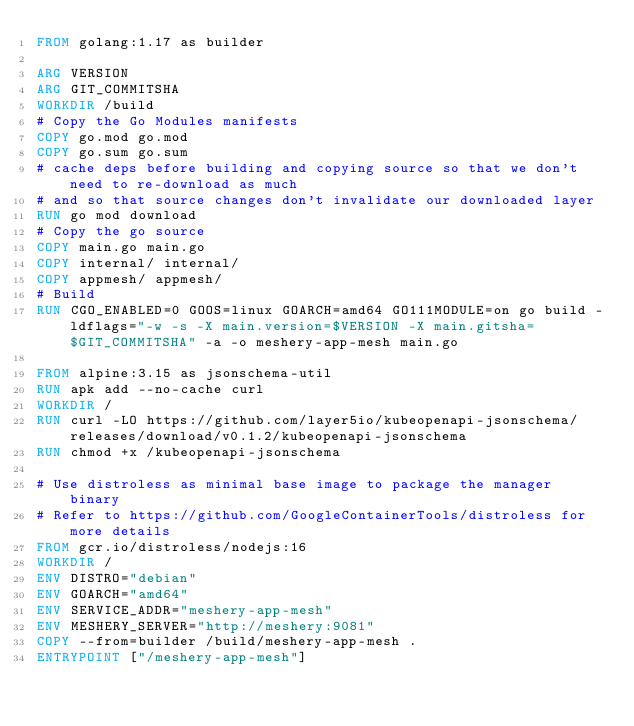Convert code to text. <code><loc_0><loc_0><loc_500><loc_500><_Dockerfile_>FROM golang:1.17 as builder

ARG VERSION
ARG GIT_COMMITSHA
WORKDIR /build
# Copy the Go Modules manifests
COPY go.mod go.mod
COPY go.sum go.sum
# cache deps before building and copying source so that we don't need to re-download as much
# and so that source changes don't invalidate our downloaded layer
RUN go mod download
# Copy the go source
COPY main.go main.go
COPY internal/ internal/
COPY appmesh/ appmesh/
# Build
RUN CGO_ENABLED=0 GOOS=linux GOARCH=amd64 GO111MODULE=on go build -ldflags="-w -s -X main.version=$VERSION -X main.gitsha=$GIT_COMMITSHA" -a -o meshery-app-mesh main.go

FROM alpine:3.15 as jsonschema-util
RUN apk add --no-cache curl
WORKDIR /
RUN curl -LO https://github.com/layer5io/kubeopenapi-jsonschema/releases/download/v0.1.2/kubeopenapi-jsonschema
RUN chmod +x /kubeopenapi-jsonschema

# Use distroless as minimal base image to package the manager binary
# Refer to https://github.com/GoogleContainerTools/distroless for more details
FROM gcr.io/distroless/nodejs:16
WORKDIR /
ENV DISTRO="debian"
ENV GOARCH="amd64"
ENV SERVICE_ADDR="meshery-app-mesh"
ENV MESHERY_SERVER="http://meshery:9081"
COPY --from=builder /build/meshery-app-mesh .
ENTRYPOINT ["/meshery-app-mesh"]
</code> 